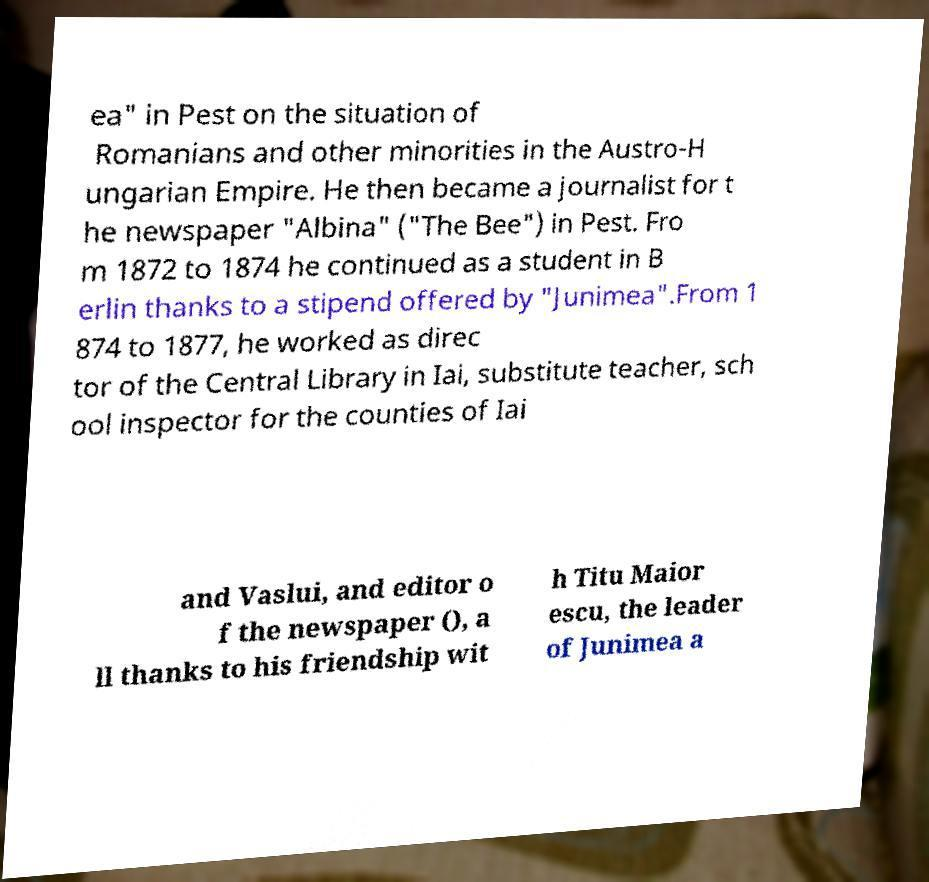Can you read and provide the text displayed in the image?This photo seems to have some interesting text. Can you extract and type it out for me? ea" in Pest on the situation of Romanians and other minorities in the Austro-H ungarian Empire. He then became a journalist for t he newspaper "Albina" ("The Bee") in Pest. Fro m 1872 to 1874 he continued as a student in B erlin thanks to a stipend offered by "Junimea".From 1 874 to 1877, he worked as direc tor of the Central Library in Iai, substitute teacher, sch ool inspector for the counties of Iai and Vaslui, and editor o f the newspaper (), a ll thanks to his friendship wit h Titu Maior escu, the leader of Junimea a 